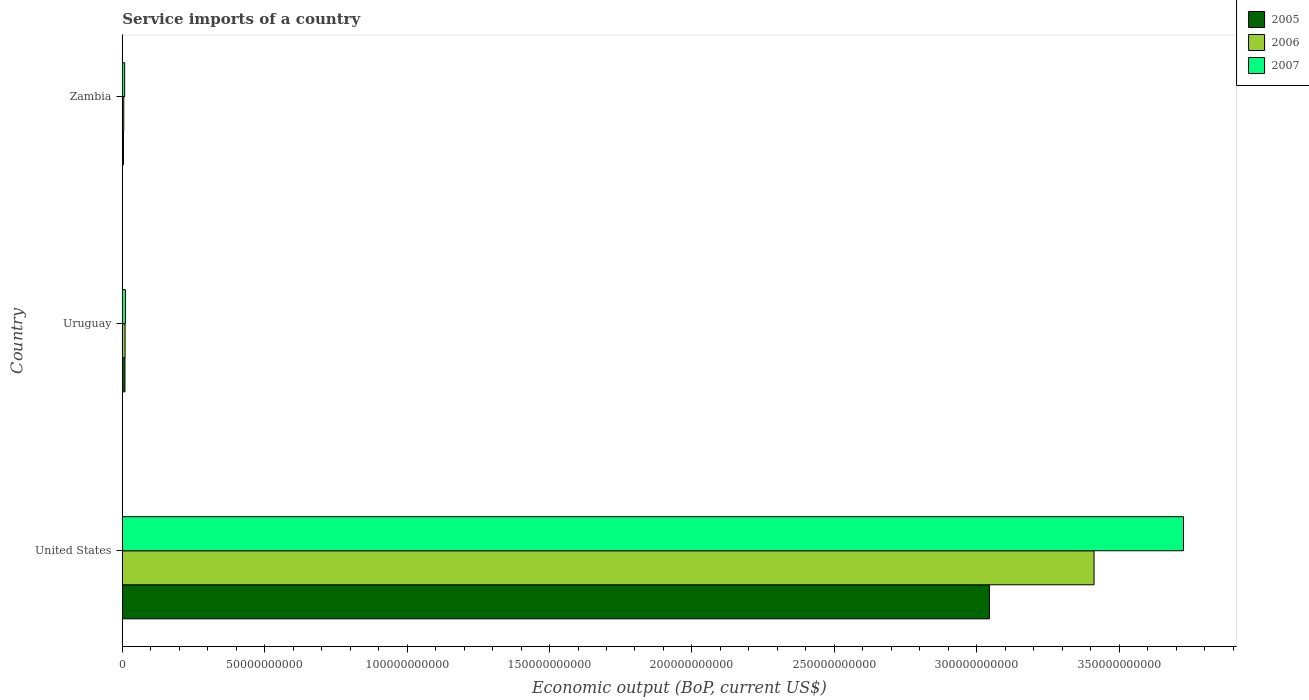How many groups of bars are there?
Offer a very short reply. 3. Are the number of bars per tick equal to the number of legend labels?
Make the answer very short. Yes. What is the label of the 2nd group of bars from the top?
Provide a succinct answer. Uruguay. What is the service imports in 2005 in United States?
Provide a succinct answer. 3.04e+11. Across all countries, what is the maximum service imports in 2007?
Ensure brevity in your answer.  3.73e+11. Across all countries, what is the minimum service imports in 2006?
Your response must be concise. 5.14e+08. In which country was the service imports in 2005 minimum?
Your answer should be compact. Zambia. What is the total service imports in 2005 in the graph?
Your answer should be compact. 3.06e+11. What is the difference between the service imports in 2007 in United States and that in Zambia?
Provide a succinct answer. 3.72e+11. What is the difference between the service imports in 2005 in United States and the service imports in 2006 in Uruguay?
Offer a terse response. 3.03e+11. What is the average service imports in 2005 per country?
Your response must be concise. 1.02e+11. What is the difference between the service imports in 2007 and service imports in 2006 in Uruguay?
Keep it short and to the point. 1.51e+08. What is the ratio of the service imports in 2005 in United States to that in Uruguay?
Make the answer very short. 324.06. Is the service imports in 2006 in Uruguay less than that in Zambia?
Offer a very short reply. No. Is the difference between the service imports in 2007 in United States and Uruguay greater than the difference between the service imports in 2006 in United States and Uruguay?
Your answer should be compact. Yes. What is the difference between the highest and the second highest service imports in 2006?
Give a very brief answer. 3.40e+11. What is the difference between the highest and the lowest service imports in 2007?
Give a very brief answer. 3.72e+11. Is the sum of the service imports in 2007 in Uruguay and Zambia greater than the maximum service imports in 2006 across all countries?
Ensure brevity in your answer.  No. What does the 2nd bar from the top in Uruguay represents?
Keep it short and to the point. 2006. What does the 2nd bar from the bottom in Zambia represents?
Ensure brevity in your answer.  2006. How many bars are there?
Your answer should be very brief. 9. Are all the bars in the graph horizontal?
Your answer should be compact. Yes. What is the difference between two consecutive major ticks on the X-axis?
Your answer should be very brief. 5.00e+1. Are the values on the major ticks of X-axis written in scientific E-notation?
Your answer should be compact. No. How many legend labels are there?
Your answer should be very brief. 3. What is the title of the graph?
Make the answer very short. Service imports of a country. Does "1984" appear as one of the legend labels in the graph?
Your answer should be compact. No. What is the label or title of the X-axis?
Offer a very short reply. Economic output (BoP, current US$). What is the label or title of the Y-axis?
Your answer should be compact. Country. What is the Economic output (BoP, current US$) in 2005 in United States?
Your response must be concise. 3.04e+11. What is the Economic output (BoP, current US$) of 2006 in United States?
Provide a succinct answer. 3.41e+11. What is the Economic output (BoP, current US$) of 2007 in United States?
Offer a terse response. 3.73e+11. What is the Economic output (BoP, current US$) of 2005 in Uruguay?
Offer a terse response. 9.39e+08. What is the Economic output (BoP, current US$) of 2006 in Uruguay?
Give a very brief answer. 9.79e+08. What is the Economic output (BoP, current US$) in 2007 in Uruguay?
Offer a very short reply. 1.13e+09. What is the Economic output (BoP, current US$) in 2005 in Zambia?
Offer a very short reply. 4.12e+08. What is the Economic output (BoP, current US$) in 2006 in Zambia?
Your response must be concise. 5.14e+08. What is the Economic output (BoP, current US$) of 2007 in Zambia?
Offer a terse response. 8.35e+08. Across all countries, what is the maximum Economic output (BoP, current US$) in 2005?
Ensure brevity in your answer.  3.04e+11. Across all countries, what is the maximum Economic output (BoP, current US$) in 2006?
Offer a terse response. 3.41e+11. Across all countries, what is the maximum Economic output (BoP, current US$) in 2007?
Your answer should be compact. 3.73e+11. Across all countries, what is the minimum Economic output (BoP, current US$) of 2005?
Ensure brevity in your answer.  4.12e+08. Across all countries, what is the minimum Economic output (BoP, current US$) of 2006?
Your answer should be compact. 5.14e+08. Across all countries, what is the minimum Economic output (BoP, current US$) of 2007?
Offer a very short reply. 8.35e+08. What is the total Economic output (BoP, current US$) of 2005 in the graph?
Make the answer very short. 3.06e+11. What is the total Economic output (BoP, current US$) of 2006 in the graph?
Give a very brief answer. 3.43e+11. What is the total Economic output (BoP, current US$) in 2007 in the graph?
Provide a short and direct response. 3.75e+11. What is the difference between the Economic output (BoP, current US$) in 2005 in United States and that in Uruguay?
Make the answer very short. 3.04e+11. What is the difference between the Economic output (BoP, current US$) in 2006 in United States and that in Uruguay?
Your response must be concise. 3.40e+11. What is the difference between the Economic output (BoP, current US$) of 2007 in United States and that in Uruguay?
Offer a terse response. 3.71e+11. What is the difference between the Economic output (BoP, current US$) of 2005 in United States and that in Zambia?
Offer a terse response. 3.04e+11. What is the difference between the Economic output (BoP, current US$) of 2006 in United States and that in Zambia?
Your response must be concise. 3.41e+11. What is the difference between the Economic output (BoP, current US$) in 2007 in United States and that in Zambia?
Provide a short and direct response. 3.72e+11. What is the difference between the Economic output (BoP, current US$) in 2005 in Uruguay and that in Zambia?
Provide a short and direct response. 5.27e+08. What is the difference between the Economic output (BoP, current US$) in 2006 in Uruguay and that in Zambia?
Your answer should be very brief. 4.65e+08. What is the difference between the Economic output (BoP, current US$) of 2007 in Uruguay and that in Zambia?
Offer a terse response. 2.95e+08. What is the difference between the Economic output (BoP, current US$) in 2005 in United States and the Economic output (BoP, current US$) in 2006 in Uruguay?
Keep it short and to the point. 3.03e+11. What is the difference between the Economic output (BoP, current US$) in 2005 in United States and the Economic output (BoP, current US$) in 2007 in Uruguay?
Give a very brief answer. 3.03e+11. What is the difference between the Economic output (BoP, current US$) in 2006 in United States and the Economic output (BoP, current US$) in 2007 in Uruguay?
Your response must be concise. 3.40e+11. What is the difference between the Economic output (BoP, current US$) in 2005 in United States and the Economic output (BoP, current US$) in 2006 in Zambia?
Give a very brief answer. 3.04e+11. What is the difference between the Economic output (BoP, current US$) of 2005 in United States and the Economic output (BoP, current US$) of 2007 in Zambia?
Offer a very short reply. 3.04e+11. What is the difference between the Economic output (BoP, current US$) in 2006 in United States and the Economic output (BoP, current US$) in 2007 in Zambia?
Your answer should be very brief. 3.40e+11. What is the difference between the Economic output (BoP, current US$) of 2005 in Uruguay and the Economic output (BoP, current US$) of 2006 in Zambia?
Make the answer very short. 4.25e+08. What is the difference between the Economic output (BoP, current US$) in 2005 in Uruguay and the Economic output (BoP, current US$) in 2007 in Zambia?
Keep it short and to the point. 1.04e+08. What is the difference between the Economic output (BoP, current US$) in 2006 in Uruguay and the Economic output (BoP, current US$) in 2007 in Zambia?
Keep it short and to the point. 1.44e+08. What is the average Economic output (BoP, current US$) of 2005 per country?
Offer a terse response. 1.02e+11. What is the average Economic output (BoP, current US$) of 2006 per country?
Ensure brevity in your answer.  1.14e+11. What is the average Economic output (BoP, current US$) in 2007 per country?
Offer a very short reply. 1.25e+11. What is the difference between the Economic output (BoP, current US$) in 2005 and Economic output (BoP, current US$) in 2006 in United States?
Give a very brief answer. -3.67e+1. What is the difference between the Economic output (BoP, current US$) in 2005 and Economic output (BoP, current US$) in 2007 in United States?
Give a very brief answer. -6.81e+1. What is the difference between the Economic output (BoP, current US$) of 2006 and Economic output (BoP, current US$) of 2007 in United States?
Your response must be concise. -3.14e+1. What is the difference between the Economic output (BoP, current US$) in 2005 and Economic output (BoP, current US$) in 2006 in Uruguay?
Your answer should be compact. -3.92e+07. What is the difference between the Economic output (BoP, current US$) of 2005 and Economic output (BoP, current US$) of 2007 in Uruguay?
Make the answer very short. -1.91e+08. What is the difference between the Economic output (BoP, current US$) of 2006 and Economic output (BoP, current US$) of 2007 in Uruguay?
Keep it short and to the point. -1.51e+08. What is the difference between the Economic output (BoP, current US$) of 2005 and Economic output (BoP, current US$) of 2006 in Zambia?
Provide a succinct answer. -1.02e+08. What is the difference between the Economic output (BoP, current US$) of 2005 and Economic output (BoP, current US$) of 2007 in Zambia?
Keep it short and to the point. -4.23e+08. What is the difference between the Economic output (BoP, current US$) in 2006 and Economic output (BoP, current US$) in 2007 in Zambia?
Your response must be concise. -3.21e+08. What is the ratio of the Economic output (BoP, current US$) in 2005 in United States to that in Uruguay?
Offer a very short reply. 324.06. What is the ratio of the Economic output (BoP, current US$) in 2006 in United States to that in Uruguay?
Make the answer very short. 348.6. What is the ratio of the Economic output (BoP, current US$) of 2007 in United States to that in Uruguay?
Your answer should be very brief. 329.71. What is the ratio of the Economic output (BoP, current US$) of 2005 in United States to that in Zambia?
Ensure brevity in your answer.  738.52. What is the ratio of the Economic output (BoP, current US$) of 2006 in United States to that in Zambia?
Give a very brief answer. 663.7. What is the ratio of the Economic output (BoP, current US$) of 2007 in United States to that in Zambia?
Your answer should be compact. 446.2. What is the ratio of the Economic output (BoP, current US$) in 2005 in Uruguay to that in Zambia?
Provide a succinct answer. 2.28. What is the ratio of the Economic output (BoP, current US$) in 2006 in Uruguay to that in Zambia?
Provide a succinct answer. 1.9. What is the ratio of the Economic output (BoP, current US$) in 2007 in Uruguay to that in Zambia?
Your answer should be compact. 1.35. What is the difference between the highest and the second highest Economic output (BoP, current US$) of 2005?
Give a very brief answer. 3.04e+11. What is the difference between the highest and the second highest Economic output (BoP, current US$) of 2006?
Offer a terse response. 3.40e+11. What is the difference between the highest and the second highest Economic output (BoP, current US$) of 2007?
Offer a very short reply. 3.71e+11. What is the difference between the highest and the lowest Economic output (BoP, current US$) of 2005?
Provide a succinct answer. 3.04e+11. What is the difference between the highest and the lowest Economic output (BoP, current US$) in 2006?
Give a very brief answer. 3.41e+11. What is the difference between the highest and the lowest Economic output (BoP, current US$) in 2007?
Offer a very short reply. 3.72e+11. 